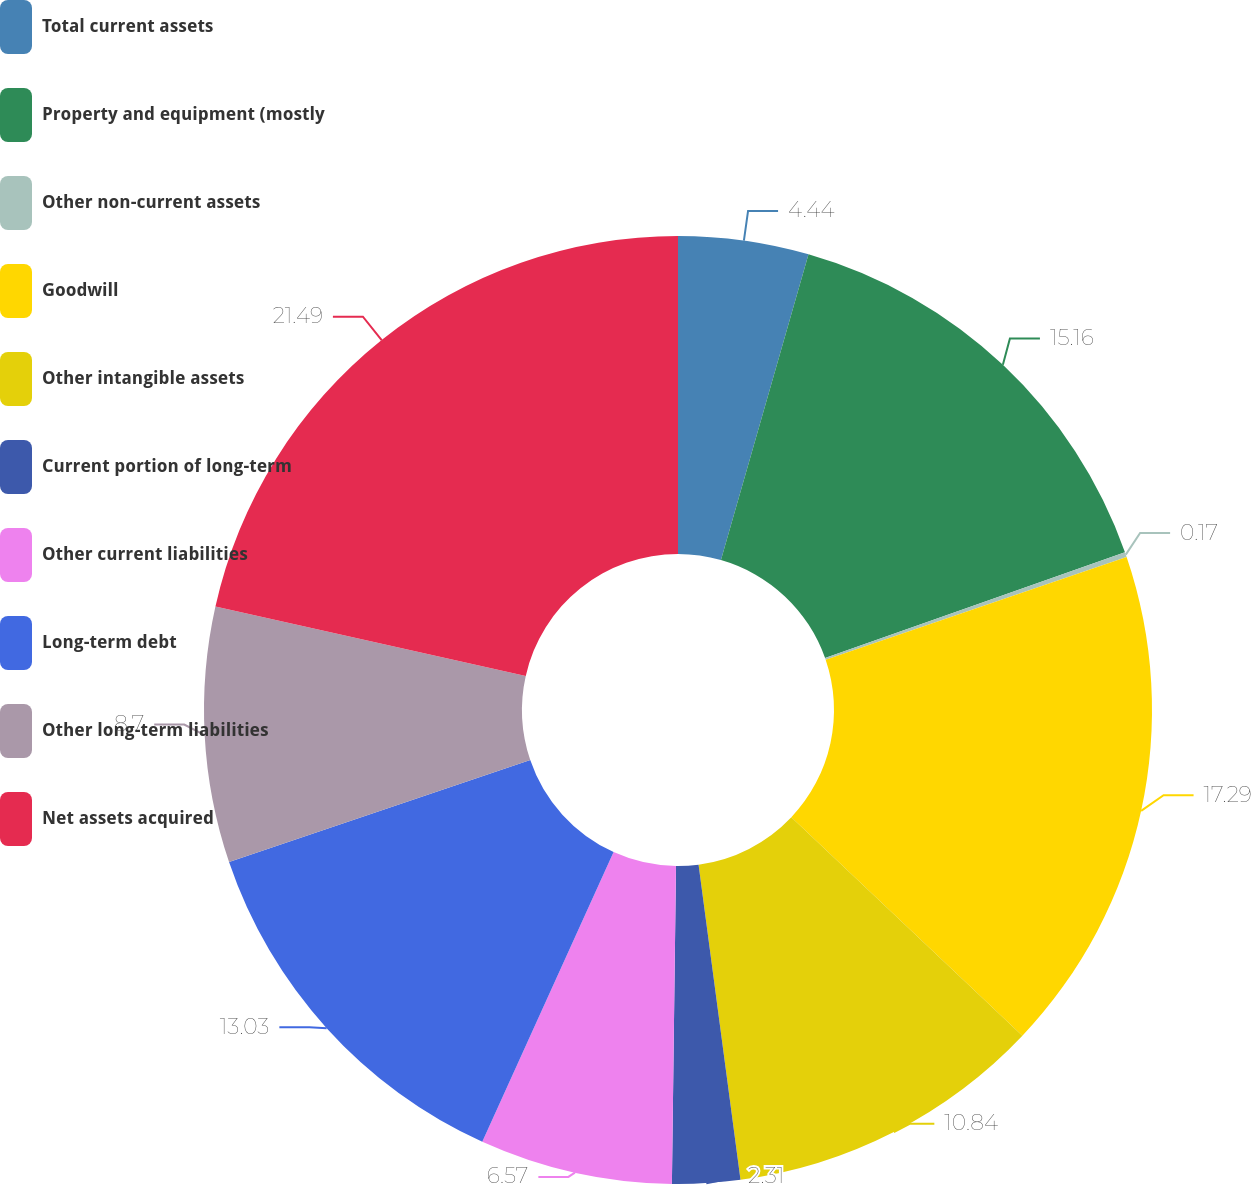Convert chart. <chart><loc_0><loc_0><loc_500><loc_500><pie_chart><fcel>Total current assets<fcel>Property and equipment (mostly<fcel>Other non-current assets<fcel>Goodwill<fcel>Other intangible assets<fcel>Current portion of long-term<fcel>Other current liabilities<fcel>Long-term debt<fcel>Other long-term liabilities<fcel>Net assets acquired<nl><fcel>4.44%<fcel>15.16%<fcel>0.17%<fcel>17.29%<fcel>10.84%<fcel>2.31%<fcel>6.57%<fcel>13.03%<fcel>8.7%<fcel>21.5%<nl></chart> 